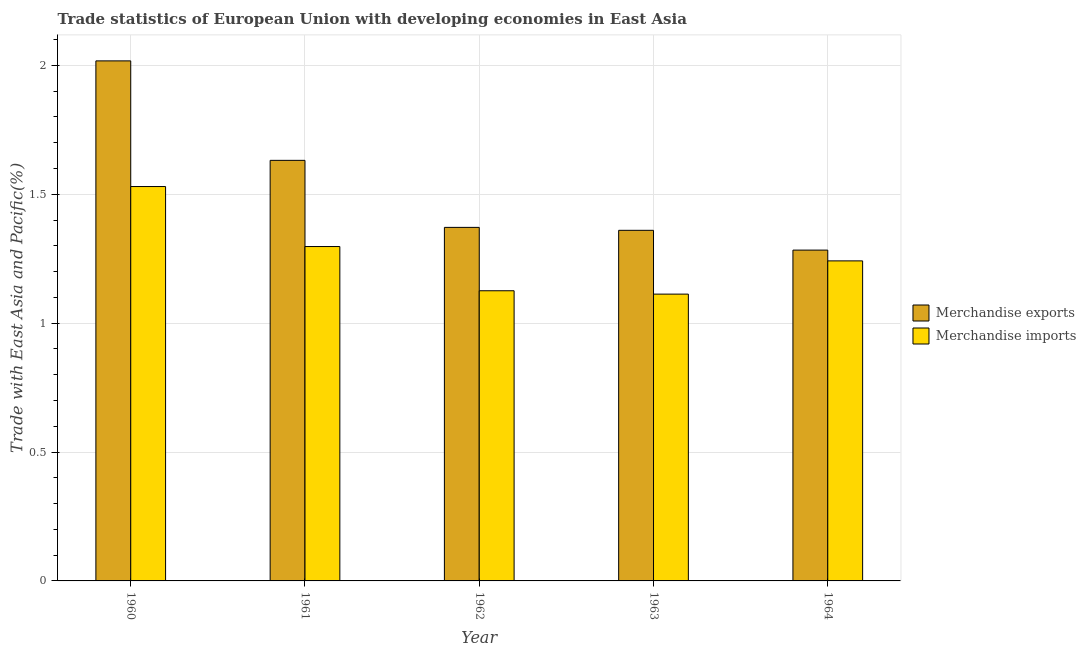Are the number of bars per tick equal to the number of legend labels?
Ensure brevity in your answer.  Yes. Are the number of bars on each tick of the X-axis equal?
Offer a terse response. Yes. How many bars are there on the 5th tick from the left?
Give a very brief answer. 2. What is the label of the 5th group of bars from the left?
Provide a succinct answer. 1964. In how many cases, is the number of bars for a given year not equal to the number of legend labels?
Keep it short and to the point. 0. What is the merchandise exports in 1963?
Offer a very short reply. 1.36. Across all years, what is the maximum merchandise exports?
Provide a short and direct response. 2.02. Across all years, what is the minimum merchandise imports?
Keep it short and to the point. 1.11. What is the total merchandise imports in the graph?
Your answer should be compact. 6.31. What is the difference between the merchandise exports in 1960 and that in 1964?
Give a very brief answer. 0.73. What is the difference between the merchandise exports in 1963 and the merchandise imports in 1964?
Keep it short and to the point. 0.08. What is the average merchandise imports per year?
Your response must be concise. 1.26. What is the ratio of the merchandise exports in 1960 to that in 1964?
Your answer should be compact. 1.57. Is the merchandise exports in 1962 less than that in 1963?
Offer a very short reply. No. What is the difference between the highest and the second highest merchandise imports?
Your response must be concise. 0.23. What is the difference between the highest and the lowest merchandise imports?
Make the answer very short. 0.42. What does the 1st bar from the left in 1964 represents?
Your answer should be compact. Merchandise exports. What does the 1st bar from the right in 1960 represents?
Your answer should be very brief. Merchandise imports. How many bars are there?
Give a very brief answer. 10. Are all the bars in the graph horizontal?
Offer a terse response. No. How many years are there in the graph?
Your answer should be very brief. 5. Are the values on the major ticks of Y-axis written in scientific E-notation?
Your response must be concise. No. Does the graph contain any zero values?
Ensure brevity in your answer.  No. Does the graph contain grids?
Offer a terse response. Yes. How many legend labels are there?
Provide a short and direct response. 2. How are the legend labels stacked?
Offer a very short reply. Vertical. What is the title of the graph?
Provide a short and direct response. Trade statistics of European Union with developing economies in East Asia. What is the label or title of the X-axis?
Offer a terse response. Year. What is the label or title of the Y-axis?
Offer a very short reply. Trade with East Asia and Pacific(%). What is the Trade with East Asia and Pacific(%) of Merchandise exports in 1960?
Ensure brevity in your answer.  2.02. What is the Trade with East Asia and Pacific(%) of Merchandise imports in 1960?
Your response must be concise. 1.53. What is the Trade with East Asia and Pacific(%) in Merchandise exports in 1961?
Your answer should be very brief. 1.63. What is the Trade with East Asia and Pacific(%) in Merchandise imports in 1961?
Give a very brief answer. 1.3. What is the Trade with East Asia and Pacific(%) of Merchandise exports in 1962?
Give a very brief answer. 1.37. What is the Trade with East Asia and Pacific(%) in Merchandise imports in 1962?
Offer a terse response. 1.13. What is the Trade with East Asia and Pacific(%) in Merchandise exports in 1963?
Your response must be concise. 1.36. What is the Trade with East Asia and Pacific(%) of Merchandise imports in 1963?
Keep it short and to the point. 1.11. What is the Trade with East Asia and Pacific(%) in Merchandise exports in 1964?
Your response must be concise. 1.28. What is the Trade with East Asia and Pacific(%) in Merchandise imports in 1964?
Your response must be concise. 1.24. Across all years, what is the maximum Trade with East Asia and Pacific(%) in Merchandise exports?
Your answer should be very brief. 2.02. Across all years, what is the maximum Trade with East Asia and Pacific(%) in Merchandise imports?
Your answer should be compact. 1.53. Across all years, what is the minimum Trade with East Asia and Pacific(%) of Merchandise exports?
Offer a terse response. 1.28. Across all years, what is the minimum Trade with East Asia and Pacific(%) of Merchandise imports?
Your answer should be compact. 1.11. What is the total Trade with East Asia and Pacific(%) of Merchandise exports in the graph?
Your answer should be compact. 7.66. What is the total Trade with East Asia and Pacific(%) in Merchandise imports in the graph?
Your answer should be very brief. 6.31. What is the difference between the Trade with East Asia and Pacific(%) of Merchandise exports in 1960 and that in 1961?
Offer a terse response. 0.39. What is the difference between the Trade with East Asia and Pacific(%) in Merchandise imports in 1960 and that in 1961?
Your response must be concise. 0.23. What is the difference between the Trade with East Asia and Pacific(%) in Merchandise exports in 1960 and that in 1962?
Offer a very short reply. 0.65. What is the difference between the Trade with East Asia and Pacific(%) of Merchandise imports in 1960 and that in 1962?
Offer a terse response. 0.4. What is the difference between the Trade with East Asia and Pacific(%) in Merchandise exports in 1960 and that in 1963?
Offer a very short reply. 0.66. What is the difference between the Trade with East Asia and Pacific(%) in Merchandise imports in 1960 and that in 1963?
Make the answer very short. 0.42. What is the difference between the Trade with East Asia and Pacific(%) in Merchandise exports in 1960 and that in 1964?
Offer a very short reply. 0.73. What is the difference between the Trade with East Asia and Pacific(%) in Merchandise imports in 1960 and that in 1964?
Keep it short and to the point. 0.29. What is the difference between the Trade with East Asia and Pacific(%) in Merchandise exports in 1961 and that in 1962?
Provide a succinct answer. 0.26. What is the difference between the Trade with East Asia and Pacific(%) in Merchandise imports in 1961 and that in 1962?
Your response must be concise. 0.17. What is the difference between the Trade with East Asia and Pacific(%) in Merchandise exports in 1961 and that in 1963?
Provide a short and direct response. 0.27. What is the difference between the Trade with East Asia and Pacific(%) of Merchandise imports in 1961 and that in 1963?
Your answer should be very brief. 0.18. What is the difference between the Trade with East Asia and Pacific(%) of Merchandise exports in 1961 and that in 1964?
Offer a very short reply. 0.35. What is the difference between the Trade with East Asia and Pacific(%) of Merchandise imports in 1961 and that in 1964?
Keep it short and to the point. 0.06. What is the difference between the Trade with East Asia and Pacific(%) of Merchandise exports in 1962 and that in 1963?
Offer a very short reply. 0.01. What is the difference between the Trade with East Asia and Pacific(%) of Merchandise imports in 1962 and that in 1963?
Your response must be concise. 0.01. What is the difference between the Trade with East Asia and Pacific(%) in Merchandise exports in 1962 and that in 1964?
Provide a short and direct response. 0.09. What is the difference between the Trade with East Asia and Pacific(%) in Merchandise imports in 1962 and that in 1964?
Keep it short and to the point. -0.12. What is the difference between the Trade with East Asia and Pacific(%) in Merchandise exports in 1963 and that in 1964?
Your answer should be compact. 0.08. What is the difference between the Trade with East Asia and Pacific(%) of Merchandise imports in 1963 and that in 1964?
Your answer should be very brief. -0.13. What is the difference between the Trade with East Asia and Pacific(%) of Merchandise exports in 1960 and the Trade with East Asia and Pacific(%) of Merchandise imports in 1961?
Provide a succinct answer. 0.72. What is the difference between the Trade with East Asia and Pacific(%) in Merchandise exports in 1960 and the Trade with East Asia and Pacific(%) in Merchandise imports in 1962?
Provide a succinct answer. 0.89. What is the difference between the Trade with East Asia and Pacific(%) of Merchandise exports in 1960 and the Trade with East Asia and Pacific(%) of Merchandise imports in 1963?
Give a very brief answer. 0.9. What is the difference between the Trade with East Asia and Pacific(%) in Merchandise exports in 1960 and the Trade with East Asia and Pacific(%) in Merchandise imports in 1964?
Give a very brief answer. 0.78. What is the difference between the Trade with East Asia and Pacific(%) of Merchandise exports in 1961 and the Trade with East Asia and Pacific(%) of Merchandise imports in 1962?
Make the answer very short. 0.51. What is the difference between the Trade with East Asia and Pacific(%) of Merchandise exports in 1961 and the Trade with East Asia and Pacific(%) of Merchandise imports in 1963?
Your response must be concise. 0.52. What is the difference between the Trade with East Asia and Pacific(%) of Merchandise exports in 1961 and the Trade with East Asia and Pacific(%) of Merchandise imports in 1964?
Offer a terse response. 0.39. What is the difference between the Trade with East Asia and Pacific(%) of Merchandise exports in 1962 and the Trade with East Asia and Pacific(%) of Merchandise imports in 1963?
Your answer should be compact. 0.26. What is the difference between the Trade with East Asia and Pacific(%) in Merchandise exports in 1962 and the Trade with East Asia and Pacific(%) in Merchandise imports in 1964?
Keep it short and to the point. 0.13. What is the difference between the Trade with East Asia and Pacific(%) of Merchandise exports in 1963 and the Trade with East Asia and Pacific(%) of Merchandise imports in 1964?
Offer a terse response. 0.12. What is the average Trade with East Asia and Pacific(%) in Merchandise exports per year?
Provide a short and direct response. 1.53. What is the average Trade with East Asia and Pacific(%) in Merchandise imports per year?
Give a very brief answer. 1.26. In the year 1960, what is the difference between the Trade with East Asia and Pacific(%) in Merchandise exports and Trade with East Asia and Pacific(%) in Merchandise imports?
Keep it short and to the point. 0.49. In the year 1961, what is the difference between the Trade with East Asia and Pacific(%) in Merchandise exports and Trade with East Asia and Pacific(%) in Merchandise imports?
Make the answer very short. 0.33. In the year 1962, what is the difference between the Trade with East Asia and Pacific(%) in Merchandise exports and Trade with East Asia and Pacific(%) in Merchandise imports?
Your response must be concise. 0.25. In the year 1963, what is the difference between the Trade with East Asia and Pacific(%) in Merchandise exports and Trade with East Asia and Pacific(%) in Merchandise imports?
Give a very brief answer. 0.25. In the year 1964, what is the difference between the Trade with East Asia and Pacific(%) of Merchandise exports and Trade with East Asia and Pacific(%) of Merchandise imports?
Make the answer very short. 0.04. What is the ratio of the Trade with East Asia and Pacific(%) of Merchandise exports in 1960 to that in 1961?
Give a very brief answer. 1.24. What is the ratio of the Trade with East Asia and Pacific(%) in Merchandise imports in 1960 to that in 1961?
Give a very brief answer. 1.18. What is the ratio of the Trade with East Asia and Pacific(%) in Merchandise exports in 1960 to that in 1962?
Provide a short and direct response. 1.47. What is the ratio of the Trade with East Asia and Pacific(%) in Merchandise imports in 1960 to that in 1962?
Offer a terse response. 1.36. What is the ratio of the Trade with East Asia and Pacific(%) in Merchandise exports in 1960 to that in 1963?
Ensure brevity in your answer.  1.48. What is the ratio of the Trade with East Asia and Pacific(%) of Merchandise imports in 1960 to that in 1963?
Your response must be concise. 1.38. What is the ratio of the Trade with East Asia and Pacific(%) in Merchandise exports in 1960 to that in 1964?
Offer a terse response. 1.57. What is the ratio of the Trade with East Asia and Pacific(%) in Merchandise imports in 1960 to that in 1964?
Your answer should be very brief. 1.23. What is the ratio of the Trade with East Asia and Pacific(%) in Merchandise exports in 1961 to that in 1962?
Keep it short and to the point. 1.19. What is the ratio of the Trade with East Asia and Pacific(%) in Merchandise imports in 1961 to that in 1962?
Your answer should be very brief. 1.15. What is the ratio of the Trade with East Asia and Pacific(%) in Merchandise exports in 1961 to that in 1963?
Ensure brevity in your answer.  1.2. What is the ratio of the Trade with East Asia and Pacific(%) of Merchandise imports in 1961 to that in 1963?
Make the answer very short. 1.17. What is the ratio of the Trade with East Asia and Pacific(%) in Merchandise exports in 1961 to that in 1964?
Your response must be concise. 1.27. What is the ratio of the Trade with East Asia and Pacific(%) of Merchandise imports in 1961 to that in 1964?
Your answer should be compact. 1.04. What is the ratio of the Trade with East Asia and Pacific(%) of Merchandise exports in 1962 to that in 1963?
Your answer should be compact. 1.01. What is the ratio of the Trade with East Asia and Pacific(%) in Merchandise imports in 1962 to that in 1963?
Provide a succinct answer. 1.01. What is the ratio of the Trade with East Asia and Pacific(%) of Merchandise exports in 1962 to that in 1964?
Your response must be concise. 1.07. What is the ratio of the Trade with East Asia and Pacific(%) in Merchandise imports in 1962 to that in 1964?
Your response must be concise. 0.91. What is the ratio of the Trade with East Asia and Pacific(%) of Merchandise exports in 1963 to that in 1964?
Your answer should be compact. 1.06. What is the ratio of the Trade with East Asia and Pacific(%) in Merchandise imports in 1963 to that in 1964?
Provide a succinct answer. 0.9. What is the difference between the highest and the second highest Trade with East Asia and Pacific(%) in Merchandise exports?
Your response must be concise. 0.39. What is the difference between the highest and the second highest Trade with East Asia and Pacific(%) of Merchandise imports?
Your answer should be very brief. 0.23. What is the difference between the highest and the lowest Trade with East Asia and Pacific(%) of Merchandise exports?
Keep it short and to the point. 0.73. What is the difference between the highest and the lowest Trade with East Asia and Pacific(%) of Merchandise imports?
Give a very brief answer. 0.42. 